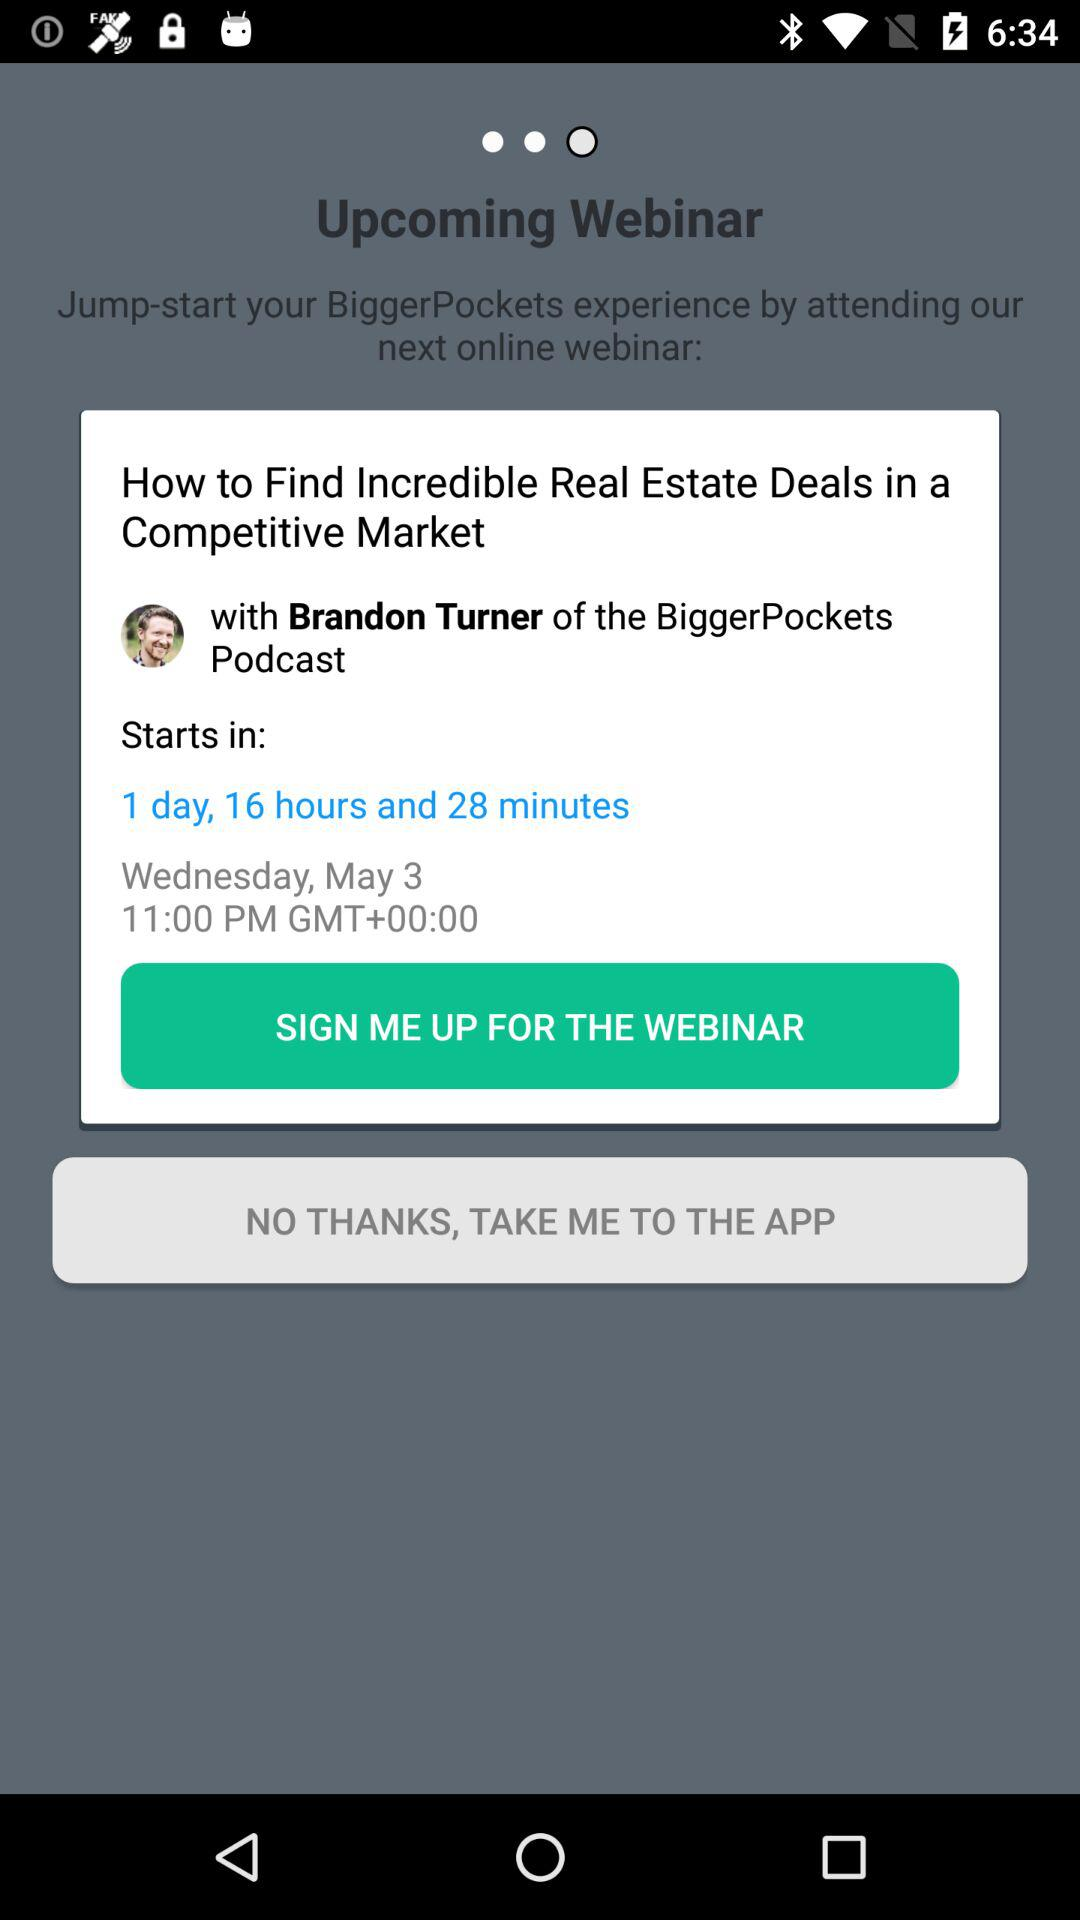When is the meeting? The meeting is on Wednesday, May 3 at 11:00 PM. 